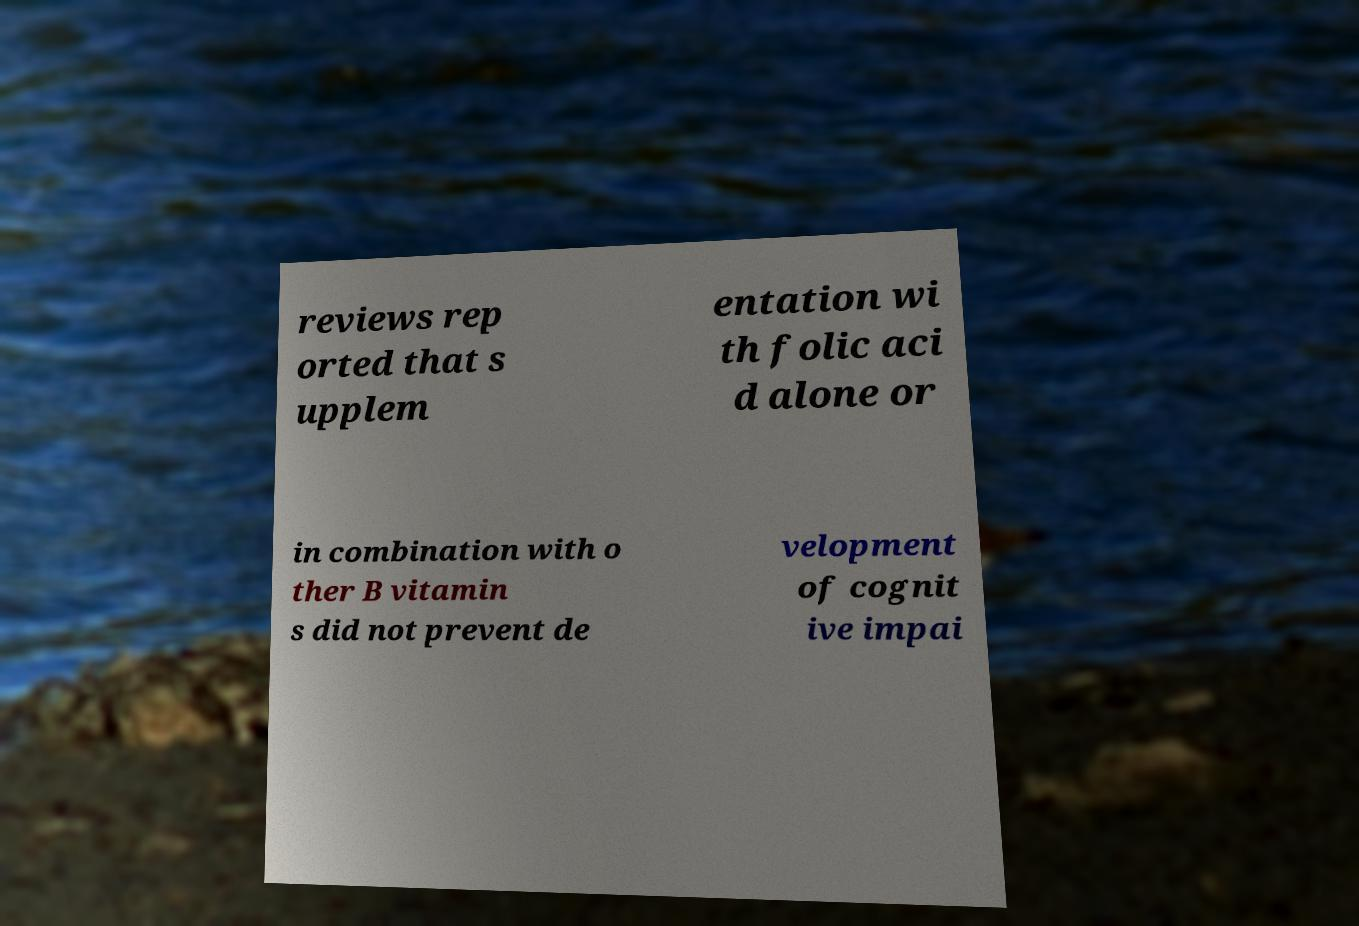There's text embedded in this image that I need extracted. Can you transcribe it verbatim? reviews rep orted that s upplem entation wi th folic aci d alone or in combination with o ther B vitamin s did not prevent de velopment of cognit ive impai 